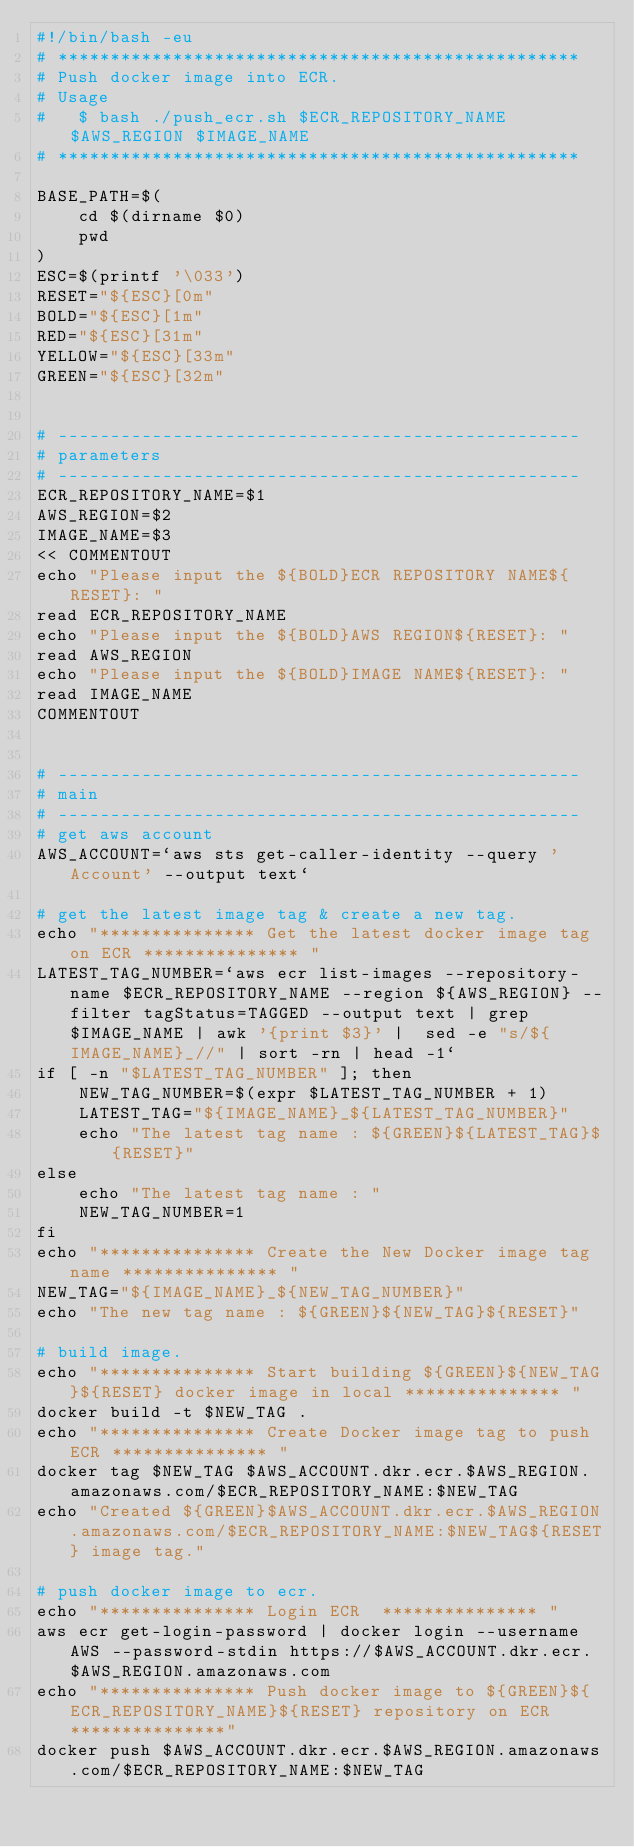Convert code to text. <code><loc_0><loc_0><loc_500><loc_500><_Bash_>#!/bin/bash -eu
# **************************************************
# Push docker image into ECR.
# Usage
#   $ bash ./push_ecr.sh $ECR_REPOSITORY_NAME $AWS_REGION $IMAGE_NAME
# **************************************************

BASE_PATH=$(
	cd $(dirname $0)
	pwd
)
ESC=$(printf '\033')
RESET="${ESC}[0m"
BOLD="${ESC}[1m"
RED="${ESC}[31m"
YELLOW="${ESC}[33m"
GREEN="${ESC}[32m"


# --------------------------------------------------
# parameters
# --------------------------------------------------
ECR_REPOSITORY_NAME=$1
AWS_REGION=$2
IMAGE_NAME=$3
<< COMMENTOUT
echo "Please input the ${BOLD}ECR REPOSITORY NAME${RESET}: "
read ECR_REPOSITORY_NAME
echo "Please input the ${BOLD}AWS REGION${RESET}: "
read AWS_REGION
echo "Please input the ${BOLD}IMAGE NAME${RESET}: "
read IMAGE_NAME
COMMENTOUT


# --------------------------------------------------
# main
# --------------------------------------------------
# get aws account
AWS_ACCOUNT=`aws sts get-caller-identity --query 'Account' --output text`

# get the latest image tag & create a new tag.
echo "*************** Get the latest docker image tag on ECR *************** "
LATEST_TAG_NUMBER=`aws ecr list-images --repository-name $ECR_REPOSITORY_NAME --region ${AWS_REGION} --filter tagStatus=TAGGED --output text | grep $IMAGE_NAME | awk '{print $3}' |  sed -e "s/${IMAGE_NAME}_//" | sort -rn | head -1`
if [ -n "$LATEST_TAG_NUMBER" ]; then
    NEW_TAG_NUMBER=$(expr $LATEST_TAG_NUMBER + 1)
    LATEST_TAG="${IMAGE_NAME}_${LATEST_TAG_NUMBER}"
    echo "The latest tag name : ${GREEN}${LATEST_TAG}${RESET}"
else
    echo "The latest tag name : "
    NEW_TAG_NUMBER=1
fi
echo "*************** Create the New Docker image tag name *************** "
NEW_TAG="${IMAGE_NAME}_${NEW_TAG_NUMBER}"
echo "The new tag name : ${GREEN}${NEW_TAG}${RESET}"

# build image.
echo "*************** Start building ${GREEN}${NEW_TAG}${RESET} docker image in local *************** "
docker build -t $NEW_TAG .
echo "*************** Create Docker image tag to push ECR *************** "
docker tag $NEW_TAG $AWS_ACCOUNT.dkr.ecr.$AWS_REGION.amazonaws.com/$ECR_REPOSITORY_NAME:$NEW_TAG
echo "Created ${GREEN}$AWS_ACCOUNT.dkr.ecr.$AWS_REGION.amazonaws.com/$ECR_REPOSITORY_NAME:$NEW_TAG${RESET} image tag."

# push docker image to ecr.
echo "*************** Login ECR  *************** "
aws ecr get-login-password | docker login --username AWS --password-stdin https://$AWS_ACCOUNT.dkr.ecr.$AWS_REGION.amazonaws.com
echo "*************** Push docker image to ${GREEN}${ECR_REPOSITORY_NAME}${RESET} repository on ECR ***************"
docker push $AWS_ACCOUNT.dkr.ecr.$AWS_REGION.amazonaws.com/$ECR_REPOSITORY_NAME:$NEW_TAG
</code> 